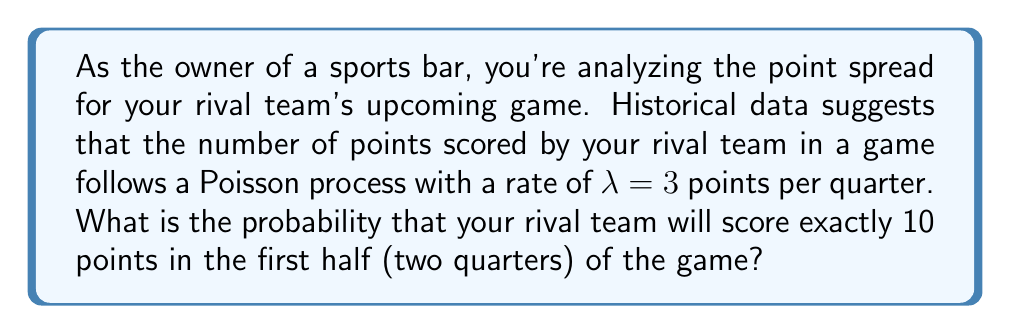Show me your answer to this math problem. Let's approach this step-by-step:

1) First, we need to recognize that we're dealing with a Poisson process over two quarters, so we need to adjust our rate:
   $\lambda_{half} = 3 \text{ points/quarter} \times 2 \text{ quarters} = 6 \text{ points/half}$

2) The probability of exactly $k$ events occurring in a Poisson process is given by the Poisson probability mass function:

   $$P(X = k) = \frac{e^{-\lambda}\lambda^k}{k!}$$

3) In this case, we want $P(X = 10)$ with $\lambda = 6$:

   $$P(X = 10) = \frac{e^{-6}6^{10}}{10!}$$

4) Let's calculate this step-by-step:
   
   $$\begin{aligned}
   P(X = 10) &= \frac{e^{-6} \times 6^{10}}{10!} \\
   &= \frac{0.00247875 \times 60466176}{3628800} \\
   &= \frac{149.8778}{3628800} \\
   &\approx 0.0413
   \end{aligned}$$

5) Converting to a percentage: $0.0413 \times 100\% = 4.13\%$

Therefore, the probability that your rival team will score exactly 10 points in the first half is approximately 4.13%.
Answer: 4.13% 